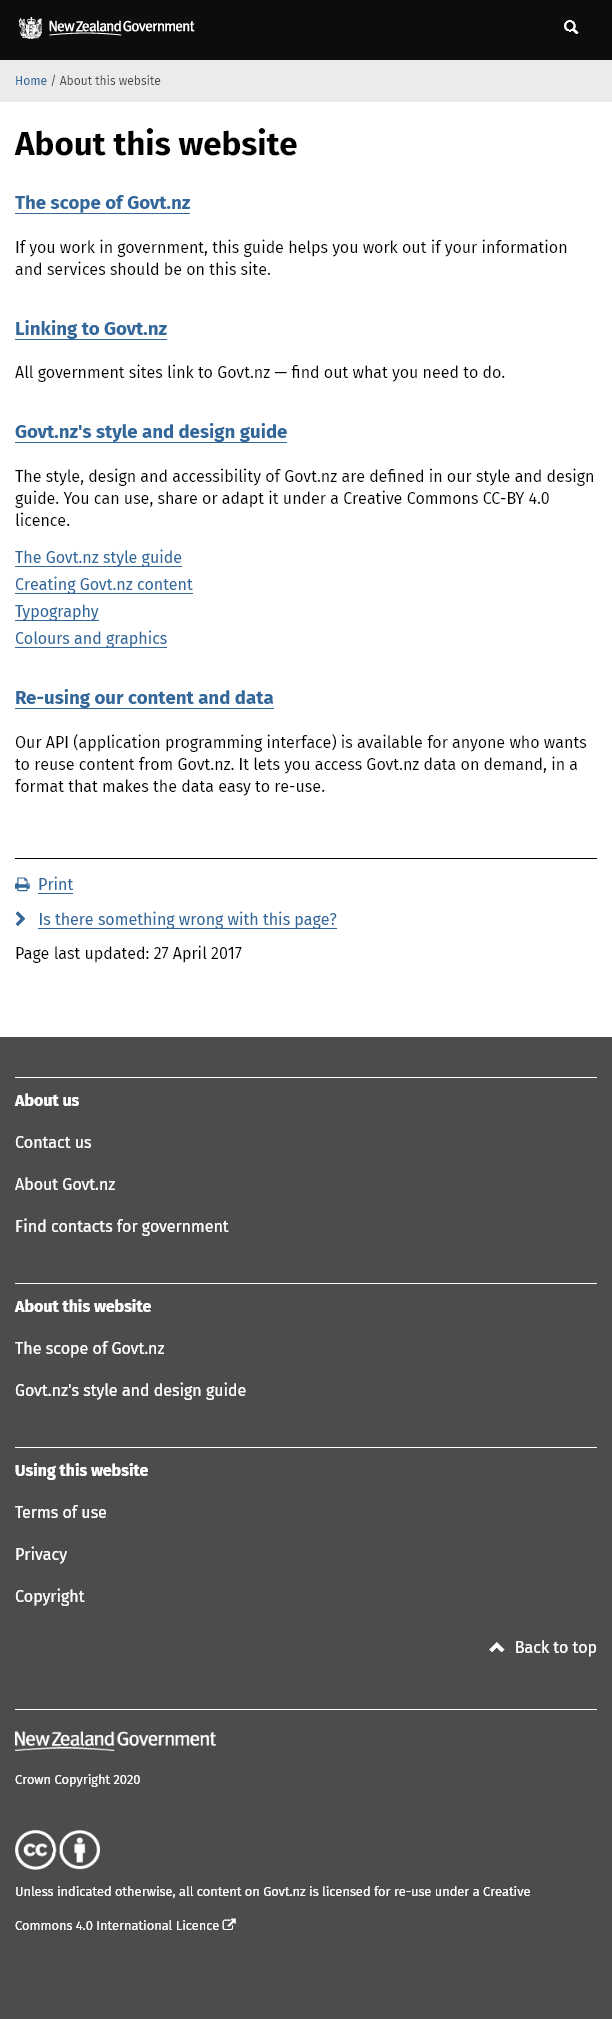Highlight a few significant elements in this photo. The Govt.nz accessibility guidelines can be found in the Govt.nz Style and Design guide. The location of links to New Zealand government websites can be found on govt.nz. I am employed by the government and can access websites through the platform "govt.nz. 